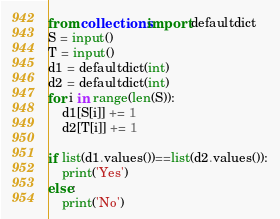<code> <loc_0><loc_0><loc_500><loc_500><_Python_>from collections import defaultdict
S = input()
T = input()
d1 = defaultdict(int)
d2 = defaultdict(int)
for i in range(len(S)):
    d1[S[i]] += 1
    d2[T[i]] += 1

if list(d1.values())==list(d2.values()):
    print('Yes')
else:
    print('No')</code> 